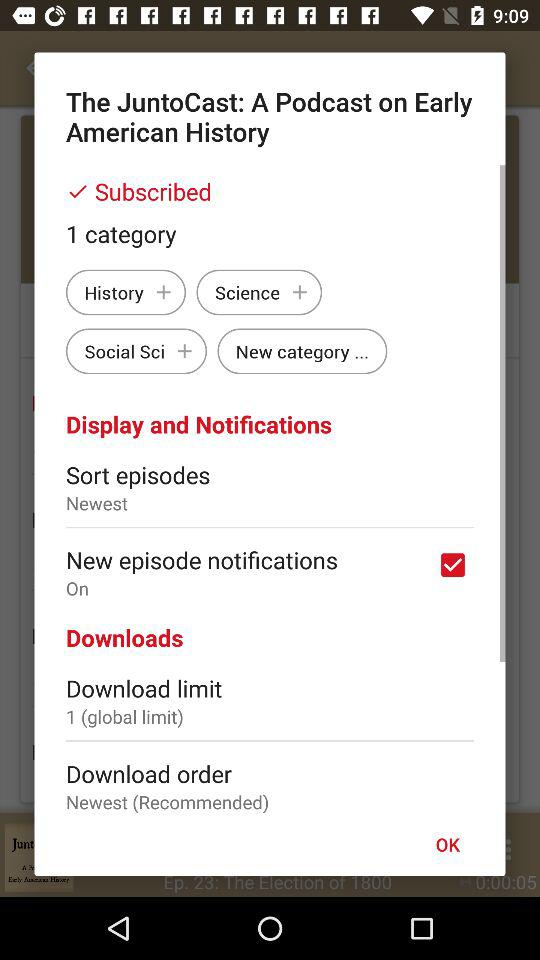What is the setting for download order? The setting is "Newest (Recommended)". 